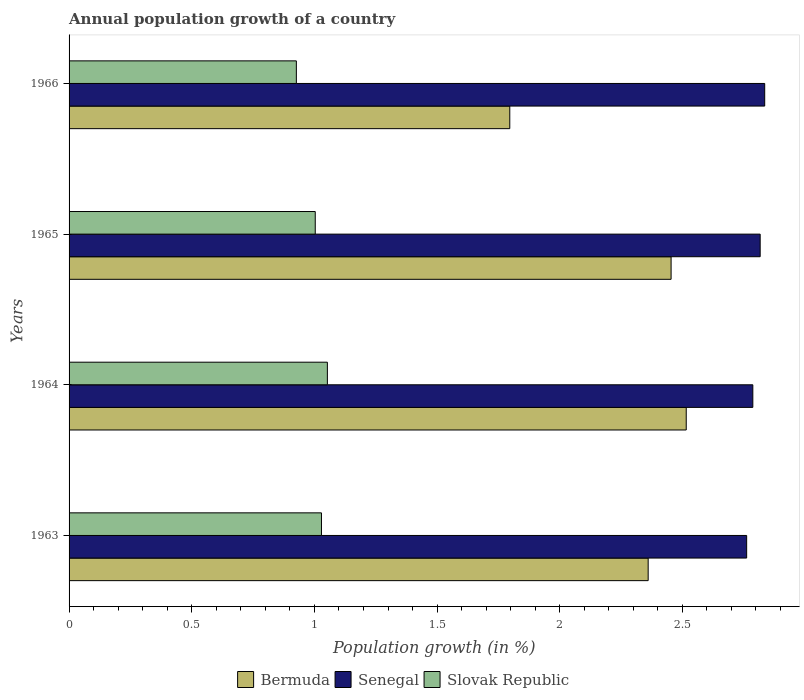Are the number of bars on each tick of the Y-axis equal?
Ensure brevity in your answer.  Yes. How many bars are there on the 3rd tick from the bottom?
Offer a very short reply. 3. What is the annual population growth in Bermuda in 1966?
Provide a short and direct response. 1.8. Across all years, what is the maximum annual population growth in Senegal?
Your response must be concise. 2.84. Across all years, what is the minimum annual population growth in Slovak Republic?
Provide a succinct answer. 0.93. In which year was the annual population growth in Slovak Republic maximum?
Provide a succinct answer. 1964. In which year was the annual population growth in Slovak Republic minimum?
Offer a terse response. 1966. What is the total annual population growth in Slovak Republic in the graph?
Provide a short and direct response. 4.01. What is the difference between the annual population growth in Senegal in 1964 and that in 1965?
Offer a very short reply. -0.03. What is the difference between the annual population growth in Senegal in 1966 and the annual population growth in Slovak Republic in 1965?
Make the answer very short. 1.83. What is the average annual population growth in Senegal per year?
Ensure brevity in your answer.  2.8. In the year 1966, what is the difference between the annual population growth in Bermuda and annual population growth in Senegal?
Your response must be concise. -1.04. In how many years, is the annual population growth in Senegal greater than 2.7 %?
Keep it short and to the point. 4. What is the ratio of the annual population growth in Senegal in 1963 to that in 1964?
Offer a terse response. 0.99. Is the annual population growth in Slovak Republic in 1963 less than that in 1965?
Keep it short and to the point. No. Is the difference between the annual population growth in Bermuda in 1963 and 1966 greater than the difference between the annual population growth in Senegal in 1963 and 1966?
Provide a succinct answer. Yes. What is the difference between the highest and the second highest annual population growth in Slovak Republic?
Provide a succinct answer. 0.02. What is the difference between the highest and the lowest annual population growth in Bermuda?
Ensure brevity in your answer.  0.72. In how many years, is the annual population growth in Slovak Republic greater than the average annual population growth in Slovak Republic taken over all years?
Provide a short and direct response. 3. What does the 1st bar from the top in 1966 represents?
Ensure brevity in your answer.  Slovak Republic. What does the 3rd bar from the bottom in 1966 represents?
Provide a succinct answer. Slovak Republic. Is it the case that in every year, the sum of the annual population growth in Bermuda and annual population growth in Slovak Republic is greater than the annual population growth in Senegal?
Your answer should be compact. No. How many bars are there?
Offer a terse response. 12. Are all the bars in the graph horizontal?
Keep it short and to the point. Yes. Are the values on the major ticks of X-axis written in scientific E-notation?
Ensure brevity in your answer.  No. Does the graph contain any zero values?
Your response must be concise. No. Does the graph contain grids?
Keep it short and to the point. No. How many legend labels are there?
Keep it short and to the point. 3. How are the legend labels stacked?
Your response must be concise. Horizontal. What is the title of the graph?
Offer a very short reply. Annual population growth of a country. What is the label or title of the X-axis?
Keep it short and to the point. Population growth (in %). What is the Population growth (in %) in Bermuda in 1963?
Give a very brief answer. 2.36. What is the Population growth (in %) of Senegal in 1963?
Offer a terse response. 2.76. What is the Population growth (in %) of Slovak Republic in 1963?
Give a very brief answer. 1.03. What is the Population growth (in %) in Bermuda in 1964?
Keep it short and to the point. 2.52. What is the Population growth (in %) of Senegal in 1964?
Your response must be concise. 2.79. What is the Population growth (in %) of Slovak Republic in 1964?
Offer a terse response. 1.05. What is the Population growth (in %) in Bermuda in 1965?
Your answer should be very brief. 2.45. What is the Population growth (in %) of Senegal in 1965?
Your answer should be very brief. 2.82. What is the Population growth (in %) in Slovak Republic in 1965?
Your answer should be compact. 1. What is the Population growth (in %) of Bermuda in 1966?
Provide a short and direct response. 1.8. What is the Population growth (in %) of Senegal in 1966?
Provide a succinct answer. 2.84. What is the Population growth (in %) in Slovak Republic in 1966?
Keep it short and to the point. 0.93. Across all years, what is the maximum Population growth (in %) of Bermuda?
Offer a very short reply. 2.52. Across all years, what is the maximum Population growth (in %) in Senegal?
Your answer should be compact. 2.84. Across all years, what is the maximum Population growth (in %) in Slovak Republic?
Offer a very short reply. 1.05. Across all years, what is the minimum Population growth (in %) in Bermuda?
Give a very brief answer. 1.8. Across all years, what is the minimum Population growth (in %) of Senegal?
Offer a terse response. 2.76. Across all years, what is the minimum Population growth (in %) in Slovak Republic?
Offer a very short reply. 0.93. What is the total Population growth (in %) in Bermuda in the graph?
Provide a short and direct response. 9.13. What is the total Population growth (in %) in Senegal in the graph?
Provide a succinct answer. 11.2. What is the total Population growth (in %) of Slovak Republic in the graph?
Your answer should be compact. 4.01. What is the difference between the Population growth (in %) of Bermuda in 1963 and that in 1964?
Your answer should be compact. -0.16. What is the difference between the Population growth (in %) in Senegal in 1963 and that in 1964?
Provide a succinct answer. -0.03. What is the difference between the Population growth (in %) in Slovak Republic in 1963 and that in 1964?
Give a very brief answer. -0.02. What is the difference between the Population growth (in %) of Bermuda in 1963 and that in 1965?
Keep it short and to the point. -0.09. What is the difference between the Population growth (in %) in Senegal in 1963 and that in 1965?
Make the answer very short. -0.06. What is the difference between the Population growth (in %) in Slovak Republic in 1963 and that in 1965?
Provide a short and direct response. 0.03. What is the difference between the Population growth (in %) of Bermuda in 1963 and that in 1966?
Give a very brief answer. 0.56. What is the difference between the Population growth (in %) in Senegal in 1963 and that in 1966?
Offer a terse response. -0.07. What is the difference between the Population growth (in %) of Slovak Republic in 1963 and that in 1966?
Make the answer very short. 0.1. What is the difference between the Population growth (in %) in Bermuda in 1964 and that in 1965?
Provide a short and direct response. 0.06. What is the difference between the Population growth (in %) in Senegal in 1964 and that in 1965?
Your response must be concise. -0.03. What is the difference between the Population growth (in %) of Slovak Republic in 1964 and that in 1965?
Offer a very short reply. 0.05. What is the difference between the Population growth (in %) of Bermuda in 1964 and that in 1966?
Your answer should be very brief. 0.72. What is the difference between the Population growth (in %) of Senegal in 1964 and that in 1966?
Your answer should be compact. -0.05. What is the difference between the Population growth (in %) in Slovak Republic in 1964 and that in 1966?
Your response must be concise. 0.13. What is the difference between the Population growth (in %) in Bermuda in 1965 and that in 1966?
Provide a succinct answer. 0.66. What is the difference between the Population growth (in %) of Senegal in 1965 and that in 1966?
Provide a short and direct response. -0.02. What is the difference between the Population growth (in %) of Slovak Republic in 1965 and that in 1966?
Your answer should be very brief. 0.08. What is the difference between the Population growth (in %) in Bermuda in 1963 and the Population growth (in %) in Senegal in 1964?
Offer a terse response. -0.43. What is the difference between the Population growth (in %) of Bermuda in 1963 and the Population growth (in %) of Slovak Republic in 1964?
Your answer should be compact. 1.31. What is the difference between the Population growth (in %) of Senegal in 1963 and the Population growth (in %) of Slovak Republic in 1964?
Make the answer very short. 1.71. What is the difference between the Population growth (in %) of Bermuda in 1963 and the Population growth (in %) of Senegal in 1965?
Your answer should be very brief. -0.46. What is the difference between the Population growth (in %) in Bermuda in 1963 and the Population growth (in %) in Slovak Republic in 1965?
Provide a succinct answer. 1.36. What is the difference between the Population growth (in %) in Senegal in 1963 and the Population growth (in %) in Slovak Republic in 1965?
Provide a short and direct response. 1.76. What is the difference between the Population growth (in %) of Bermuda in 1963 and the Population growth (in %) of Senegal in 1966?
Give a very brief answer. -0.48. What is the difference between the Population growth (in %) of Bermuda in 1963 and the Population growth (in %) of Slovak Republic in 1966?
Offer a very short reply. 1.43. What is the difference between the Population growth (in %) of Senegal in 1963 and the Population growth (in %) of Slovak Republic in 1966?
Ensure brevity in your answer.  1.84. What is the difference between the Population growth (in %) of Bermuda in 1964 and the Population growth (in %) of Senegal in 1965?
Your answer should be compact. -0.3. What is the difference between the Population growth (in %) of Bermuda in 1964 and the Population growth (in %) of Slovak Republic in 1965?
Provide a succinct answer. 1.51. What is the difference between the Population growth (in %) in Senegal in 1964 and the Population growth (in %) in Slovak Republic in 1965?
Keep it short and to the point. 1.78. What is the difference between the Population growth (in %) in Bermuda in 1964 and the Population growth (in %) in Senegal in 1966?
Provide a short and direct response. -0.32. What is the difference between the Population growth (in %) of Bermuda in 1964 and the Population growth (in %) of Slovak Republic in 1966?
Keep it short and to the point. 1.59. What is the difference between the Population growth (in %) of Senegal in 1964 and the Population growth (in %) of Slovak Republic in 1966?
Give a very brief answer. 1.86. What is the difference between the Population growth (in %) in Bermuda in 1965 and the Population growth (in %) in Senegal in 1966?
Make the answer very short. -0.38. What is the difference between the Population growth (in %) in Bermuda in 1965 and the Population growth (in %) in Slovak Republic in 1966?
Ensure brevity in your answer.  1.53. What is the difference between the Population growth (in %) in Senegal in 1965 and the Population growth (in %) in Slovak Republic in 1966?
Your answer should be compact. 1.89. What is the average Population growth (in %) of Bermuda per year?
Your answer should be compact. 2.28. What is the average Population growth (in %) of Senegal per year?
Provide a short and direct response. 2.8. In the year 1963, what is the difference between the Population growth (in %) of Bermuda and Population growth (in %) of Senegal?
Provide a succinct answer. -0.4. In the year 1963, what is the difference between the Population growth (in %) of Bermuda and Population growth (in %) of Slovak Republic?
Provide a short and direct response. 1.33. In the year 1963, what is the difference between the Population growth (in %) of Senegal and Population growth (in %) of Slovak Republic?
Provide a short and direct response. 1.73. In the year 1964, what is the difference between the Population growth (in %) in Bermuda and Population growth (in %) in Senegal?
Keep it short and to the point. -0.27. In the year 1964, what is the difference between the Population growth (in %) of Bermuda and Population growth (in %) of Slovak Republic?
Make the answer very short. 1.46. In the year 1964, what is the difference between the Population growth (in %) in Senegal and Population growth (in %) in Slovak Republic?
Offer a very short reply. 1.73. In the year 1965, what is the difference between the Population growth (in %) in Bermuda and Population growth (in %) in Senegal?
Provide a short and direct response. -0.36. In the year 1965, what is the difference between the Population growth (in %) of Bermuda and Population growth (in %) of Slovak Republic?
Provide a short and direct response. 1.45. In the year 1965, what is the difference between the Population growth (in %) in Senegal and Population growth (in %) in Slovak Republic?
Provide a short and direct response. 1.81. In the year 1966, what is the difference between the Population growth (in %) in Bermuda and Population growth (in %) in Senegal?
Keep it short and to the point. -1.04. In the year 1966, what is the difference between the Population growth (in %) of Bermuda and Population growth (in %) of Slovak Republic?
Give a very brief answer. 0.87. In the year 1966, what is the difference between the Population growth (in %) in Senegal and Population growth (in %) in Slovak Republic?
Provide a succinct answer. 1.91. What is the ratio of the Population growth (in %) of Bermuda in 1963 to that in 1964?
Your answer should be compact. 0.94. What is the ratio of the Population growth (in %) in Senegal in 1963 to that in 1964?
Ensure brevity in your answer.  0.99. What is the ratio of the Population growth (in %) in Slovak Republic in 1963 to that in 1964?
Give a very brief answer. 0.98. What is the ratio of the Population growth (in %) in Bermuda in 1963 to that in 1965?
Provide a short and direct response. 0.96. What is the ratio of the Population growth (in %) of Senegal in 1963 to that in 1965?
Keep it short and to the point. 0.98. What is the ratio of the Population growth (in %) in Slovak Republic in 1963 to that in 1965?
Offer a terse response. 1.03. What is the ratio of the Population growth (in %) in Bermuda in 1963 to that in 1966?
Keep it short and to the point. 1.31. What is the ratio of the Population growth (in %) of Senegal in 1963 to that in 1966?
Provide a succinct answer. 0.97. What is the ratio of the Population growth (in %) in Slovak Republic in 1963 to that in 1966?
Provide a succinct answer. 1.11. What is the ratio of the Population growth (in %) of Bermuda in 1964 to that in 1965?
Make the answer very short. 1.03. What is the ratio of the Population growth (in %) in Senegal in 1964 to that in 1965?
Provide a short and direct response. 0.99. What is the ratio of the Population growth (in %) of Slovak Republic in 1964 to that in 1965?
Your response must be concise. 1.05. What is the ratio of the Population growth (in %) of Bermuda in 1964 to that in 1966?
Provide a short and direct response. 1.4. What is the ratio of the Population growth (in %) of Senegal in 1964 to that in 1966?
Offer a very short reply. 0.98. What is the ratio of the Population growth (in %) of Slovak Republic in 1964 to that in 1966?
Ensure brevity in your answer.  1.14. What is the ratio of the Population growth (in %) in Bermuda in 1965 to that in 1966?
Provide a succinct answer. 1.37. What is the ratio of the Population growth (in %) in Slovak Republic in 1965 to that in 1966?
Give a very brief answer. 1.08. What is the difference between the highest and the second highest Population growth (in %) of Bermuda?
Your answer should be compact. 0.06. What is the difference between the highest and the second highest Population growth (in %) in Senegal?
Give a very brief answer. 0.02. What is the difference between the highest and the second highest Population growth (in %) in Slovak Republic?
Offer a very short reply. 0.02. What is the difference between the highest and the lowest Population growth (in %) in Bermuda?
Make the answer very short. 0.72. What is the difference between the highest and the lowest Population growth (in %) in Senegal?
Offer a very short reply. 0.07. What is the difference between the highest and the lowest Population growth (in %) in Slovak Republic?
Give a very brief answer. 0.13. 